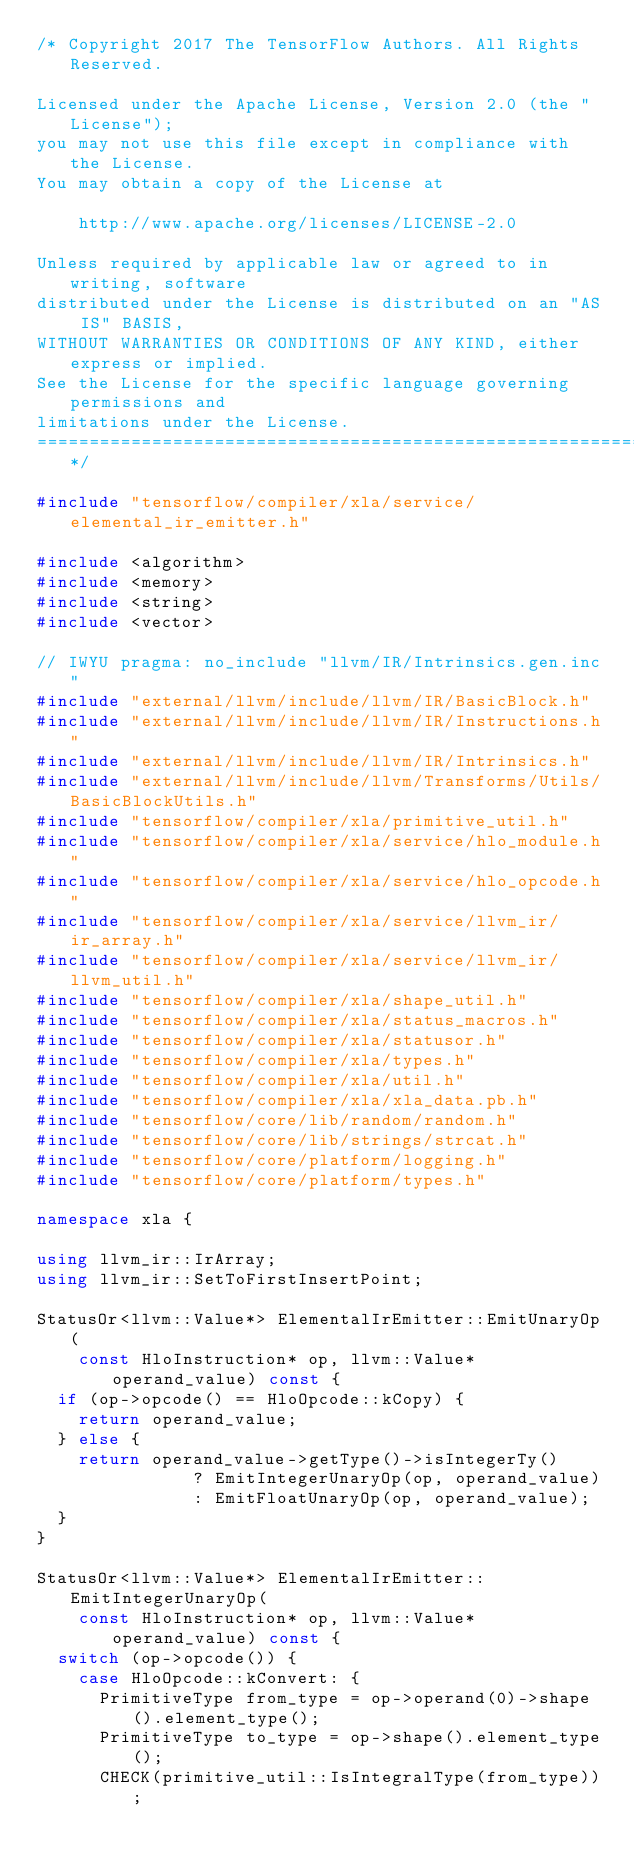Convert code to text. <code><loc_0><loc_0><loc_500><loc_500><_C++_>/* Copyright 2017 The TensorFlow Authors. All Rights Reserved.

Licensed under the Apache License, Version 2.0 (the "License");
you may not use this file except in compliance with the License.
You may obtain a copy of the License at

    http://www.apache.org/licenses/LICENSE-2.0

Unless required by applicable law or agreed to in writing, software
distributed under the License is distributed on an "AS IS" BASIS,
WITHOUT WARRANTIES OR CONDITIONS OF ANY KIND, either express or implied.
See the License for the specific language governing permissions and
limitations under the License.
==============================================================================*/

#include "tensorflow/compiler/xla/service/elemental_ir_emitter.h"

#include <algorithm>
#include <memory>
#include <string>
#include <vector>

// IWYU pragma: no_include "llvm/IR/Intrinsics.gen.inc"
#include "external/llvm/include/llvm/IR/BasicBlock.h"
#include "external/llvm/include/llvm/IR/Instructions.h"
#include "external/llvm/include/llvm/IR/Intrinsics.h"
#include "external/llvm/include/llvm/Transforms/Utils/BasicBlockUtils.h"
#include "tensorflow/compiler/xla/primitive_util.h"
#include "tensorflow/compiler/xla/service/hlo_module.h"
#include "tensorflow/compiler/xla/service/hlo_opcode.h"
#include "tensorflow/compiler/xla/service/llvm_ir/ir_array.h"
#include "tensorflow/compiler/xla/service/llvm_ir/llvm_util.h"
#include "tensorflow/compiler/xla/shape_util.h"
#include "tensorflow/compiler/xla/status_macros.h"
#include "tensorflow/compiler/xla/statusor.h"
#include "tensorflow/compiler/xla/types.h"
#include "tensorflow/compiler/xla/util.h"
#include "tensorflow/compiler/xla/xla_data.pb.h"
#include "tensorflow/core/lib/random/random.h"
#include "tensorflow/core/lib/strings/strcat.h"
#include "tensorflow/core/platform/logging.h"
#include "tensorflow/core/platform/types.h"

namespace xla {

using llvm_ir::IrArray;
using llvm_ir::SetToFirstInsertPoint;

StatusOr<llvm::Value*> ElementalIrEmitter::EmitUnaryOp(
    const HloInstruction* op, llvm::Value* operand_value) const {
  if (op->opcode() == HloOpcode::kCopy) {
    return operand_value;
  } else {
    return operand_value->getType()->isIntegerTy()
               ? EmitIntegerUnaryOp(op, operand_value)
               : EmitFloatUnaryOp(op, operand_value);
  }
}

StatusOr<llvm::Value*> ElementalIrEmitter::EmitIntegerUnaryOp(
    const HloInstruction* op, llvm::Value* operand_value) const {
  switch (op->opcode()) {
    case HloOpcode::kConvert: {
      PrimitiveType from_type = op->operand(0)->shape().element_type();
      PrimitiveType to_type = op->shape().element_type();
      CHECK(primitive_util::IsIntegralType(from_type));</code> 